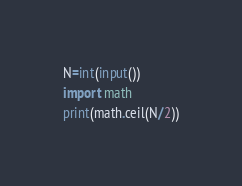<code> <loc_0><loc_0><loc_500><loc_500><_Python_>N=int(input())
import math
print(math.ceil(N/2))</code> 